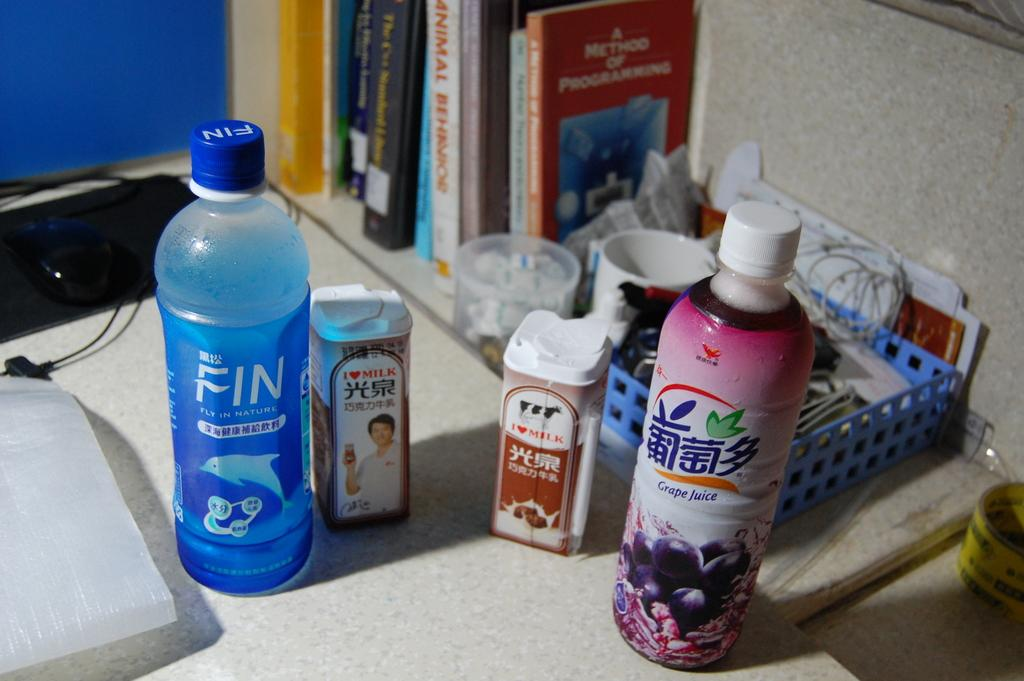<image>
Relay a brief, clear account of the picture shown. A bottle of FIN drink id on a desk with other beverages. 